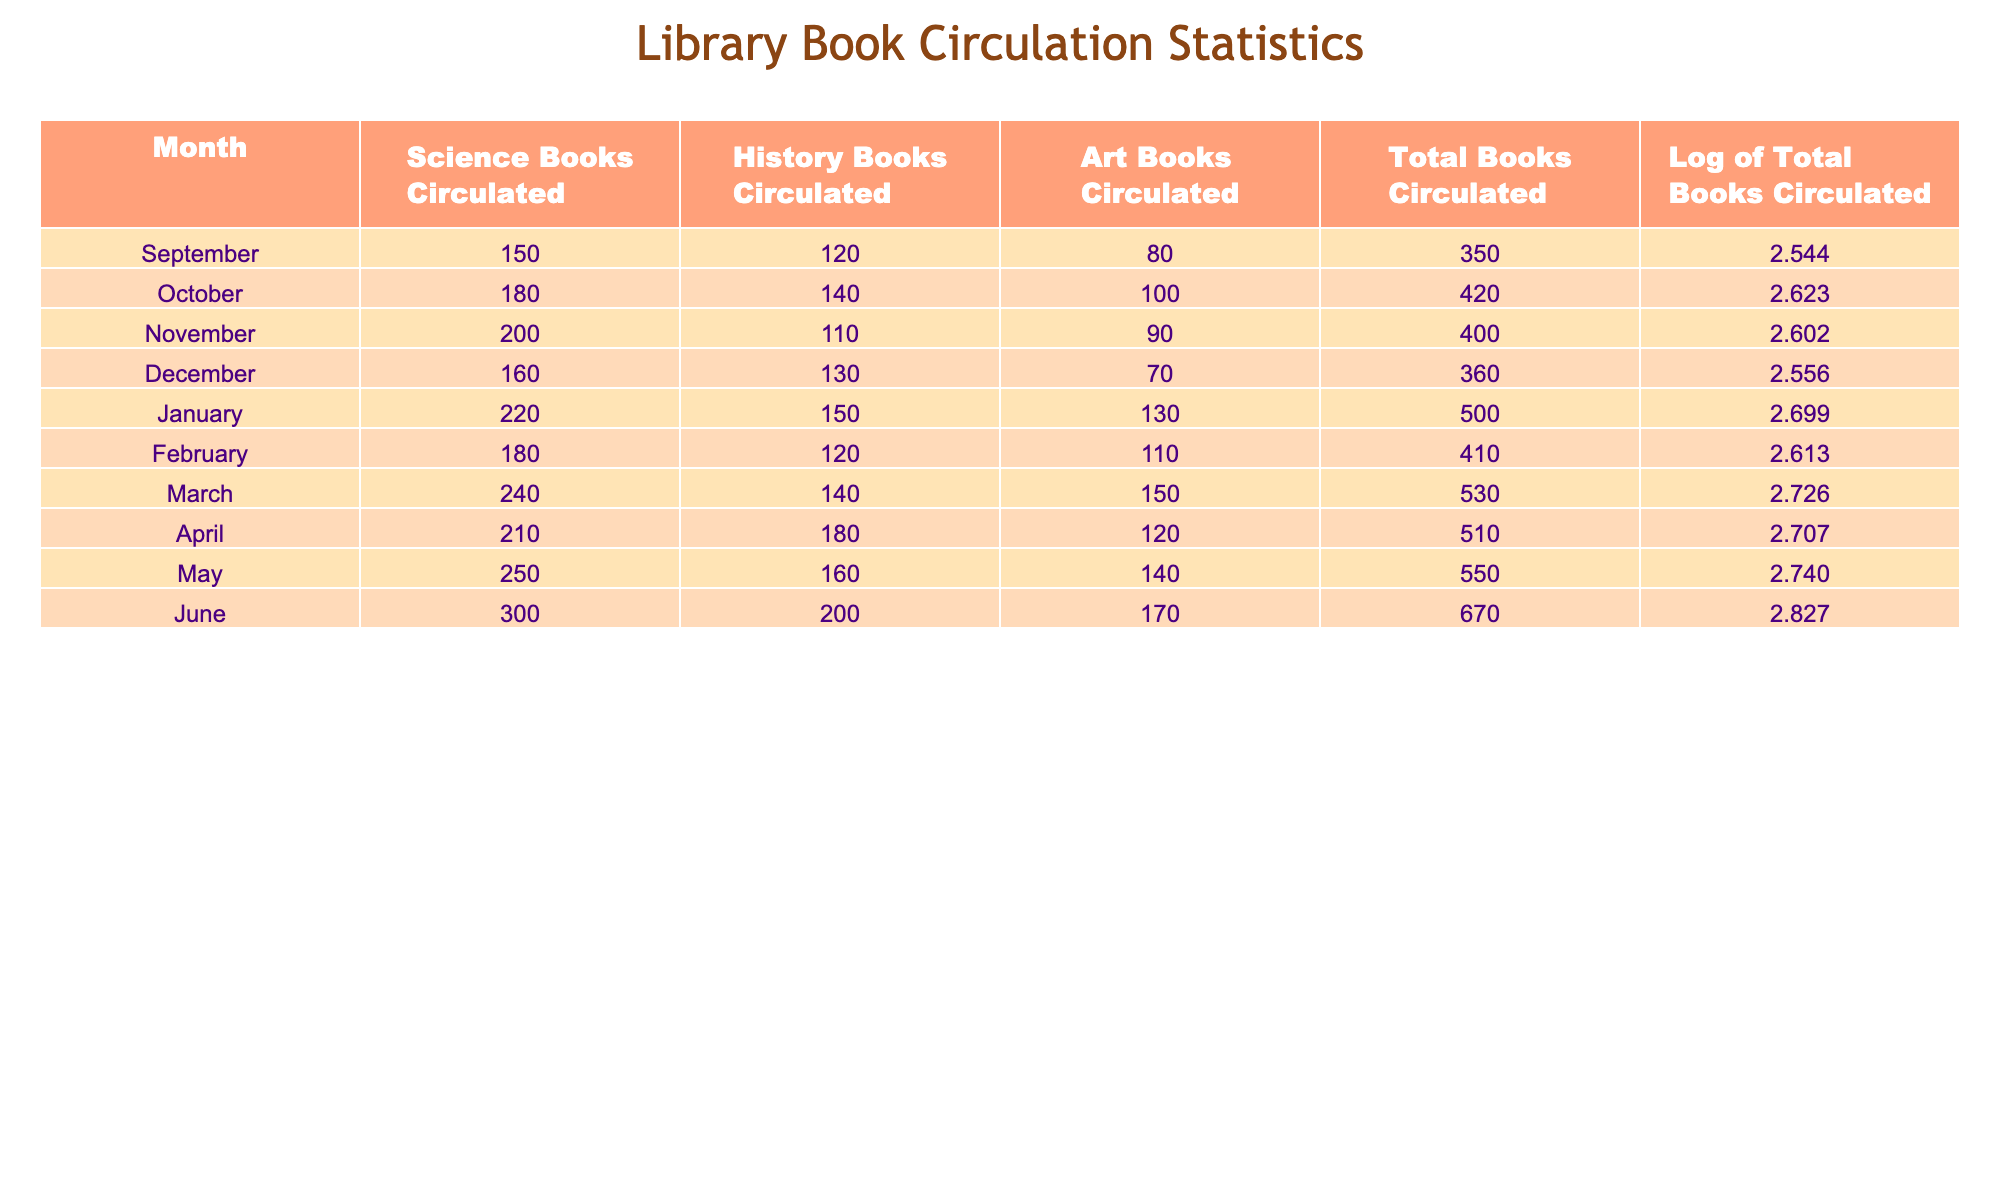What month had the highest total books circulated? Looking through the "Total Books Circulated" column, June shows the highest value at 670.
Answer: June What was the total circulation of Art books in February? Referring to the "Art Books Circulated" column for February, the figure is 110.
Answer: 110 Did more Science books or History books circulate in November? In November, 200 Science books and 110 History books were circulated. Since 200 is greater than 110, more Science books circulated.
Answer: Yes What is the average number of Science books circulated over the school year? Adding the Science books from all months: 150 + 180 + 200 + 160 + 220 + 180 + 240 + 210 + 250 + 300 = 1870. There are 10 months, so the average is 1870/10 = 187.
Answer: 187 Which month had the lowest total books circulated? Scanning the "Total Books Circulated" column, December shows the lowest total with 360.
Answer: December What was the total circulation of books from January to March? Summing the totals for January (500), February (410), and March (530) gives: 500 + 410 + 530 = 1440.
Answer: 1440 Is the logarithm of total books circulated for April higher than for December? The log for April is 2.707 and for December is 2.556. Since 2.707 is indeed higher than 2.556, the statement is true.
Answer: Yes What was the percentage increase in total books circulated from April to June? The total for April is 510 and for June is 670. The increase is 670 - 510 = 160. The percentage increase is (160/510) * 100 ≈ 31.37%.
Answer: 31.37% What is the total number of History books circulated from September to February? Adding History books from September (120), October (140), November (110), December (130), January (150), and February (120): 120 + 140 + 110 + 130 + 150 + 120 = 770.
Answer: 770 